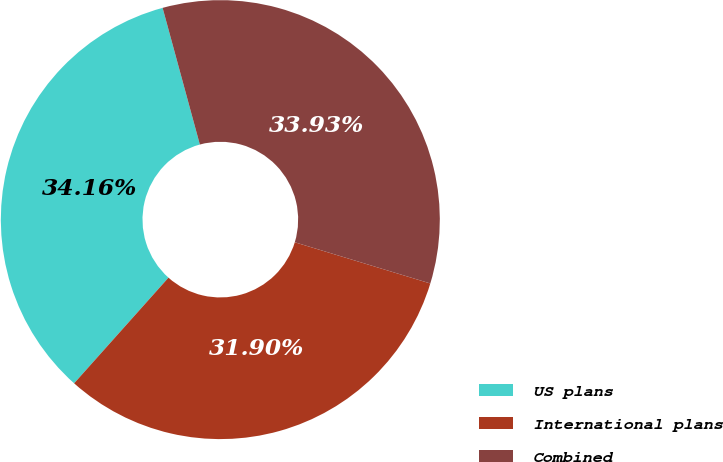<chart> <loc_0><loc_0><loc_500><loc_500><pie_chart><fcel>US plans<fcel>International plans<fcel>Combined<nl><fcel>34.16%<fcel>31.9%<fcel>33.93%<nl></chart> 